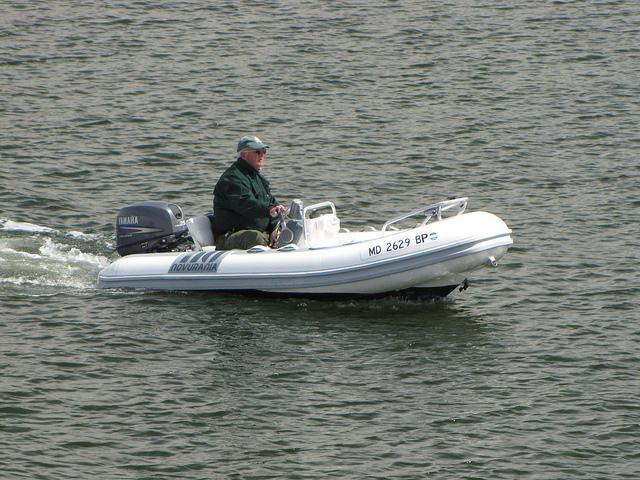How many people are in the boat?
Give a very brief answer. 1. 